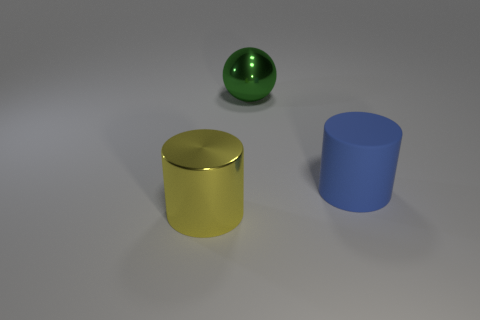Add 3 large metallic objects. How many objects exist? 6 Subtract all spheres. How many objects are left? 2 Subtract 0 gray balls. How many objects are left? 3 Subtract all yellow things. Subtract all rubber objects. How many objects are left? 1 Add 1 shiny balls. How many shiny balls are left? 2 Add 1 cyan rubber blocks. How many cyan rubber blocks exist? 1 